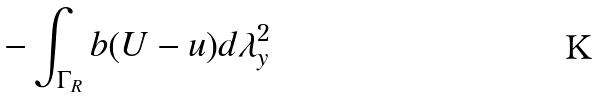<formula> <loc_0><loc_0><loc_500><loc_500>- \int _ { \Gamma _ { R } } b ( U - u ) d \lambda ^ { 2 } _ { y }</formula> 